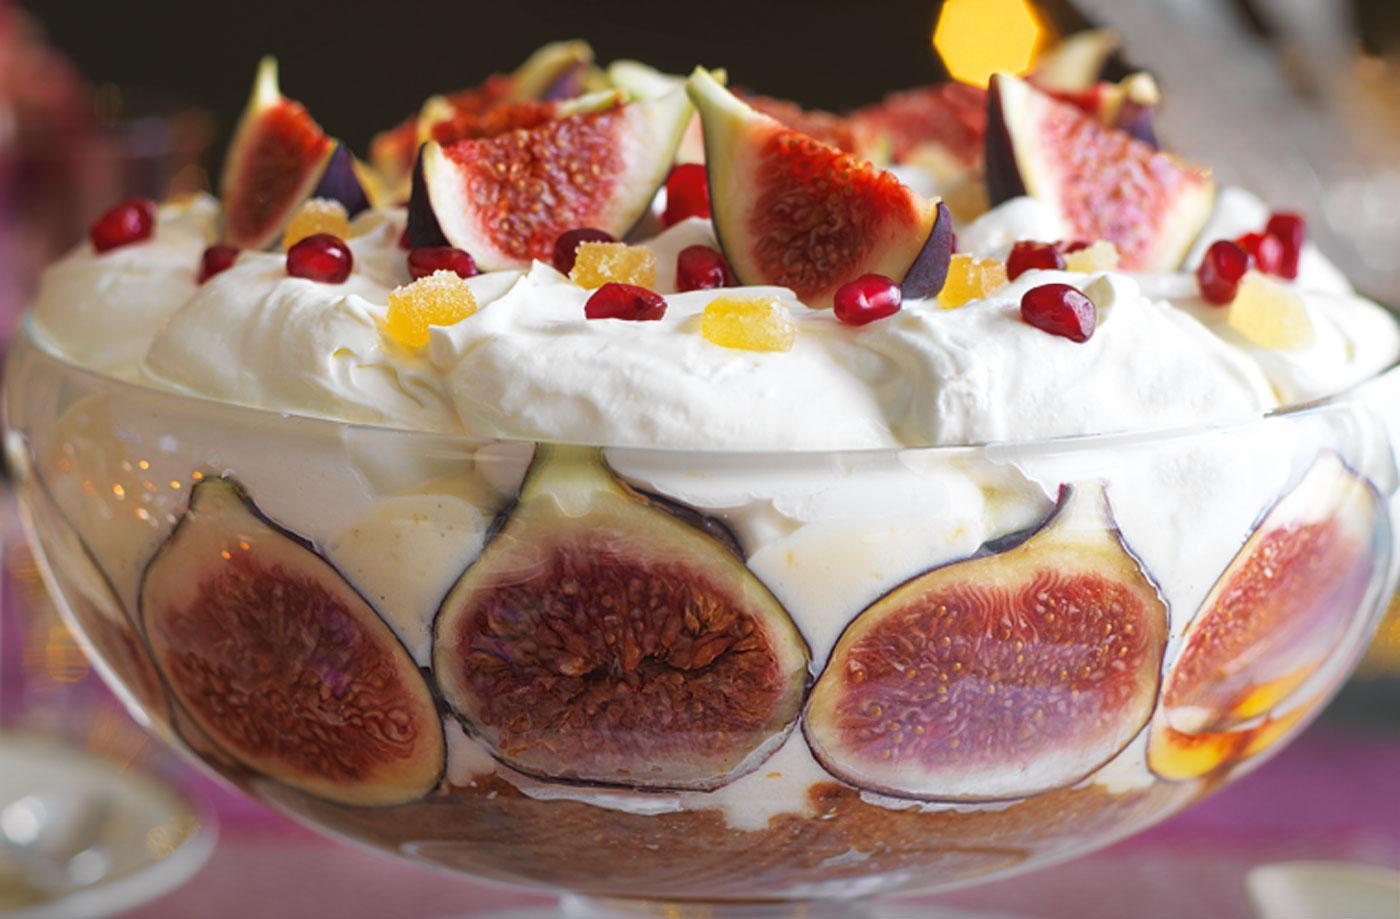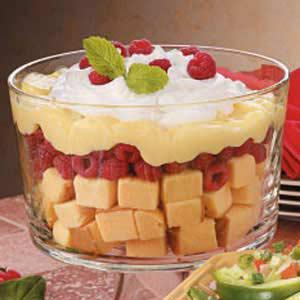The first image is the image on the left, the second image is the image on the right. Considering the images on both sides, is "The desserts in one of the images are dished out into single servings." valid? Answer yes or no. No. 